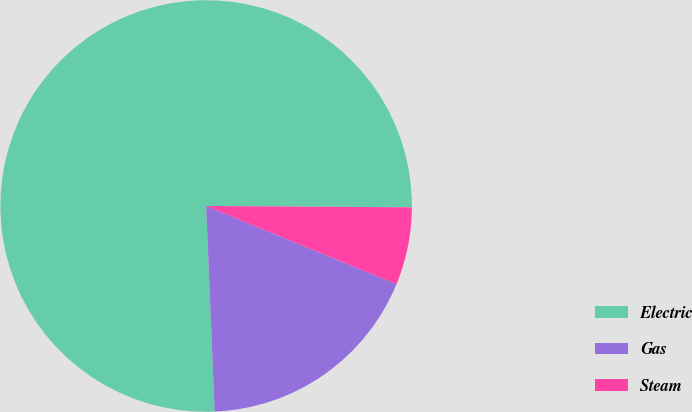Convert chart. <chart><loc_0><loc_0><loc_500><loc_500><pie_chart><fcel>Electric<fcel>Gas<fcel>Steam<nl><fcel>75.76%<fcel>18.14%<fcel>6.1%<nl></chart> 